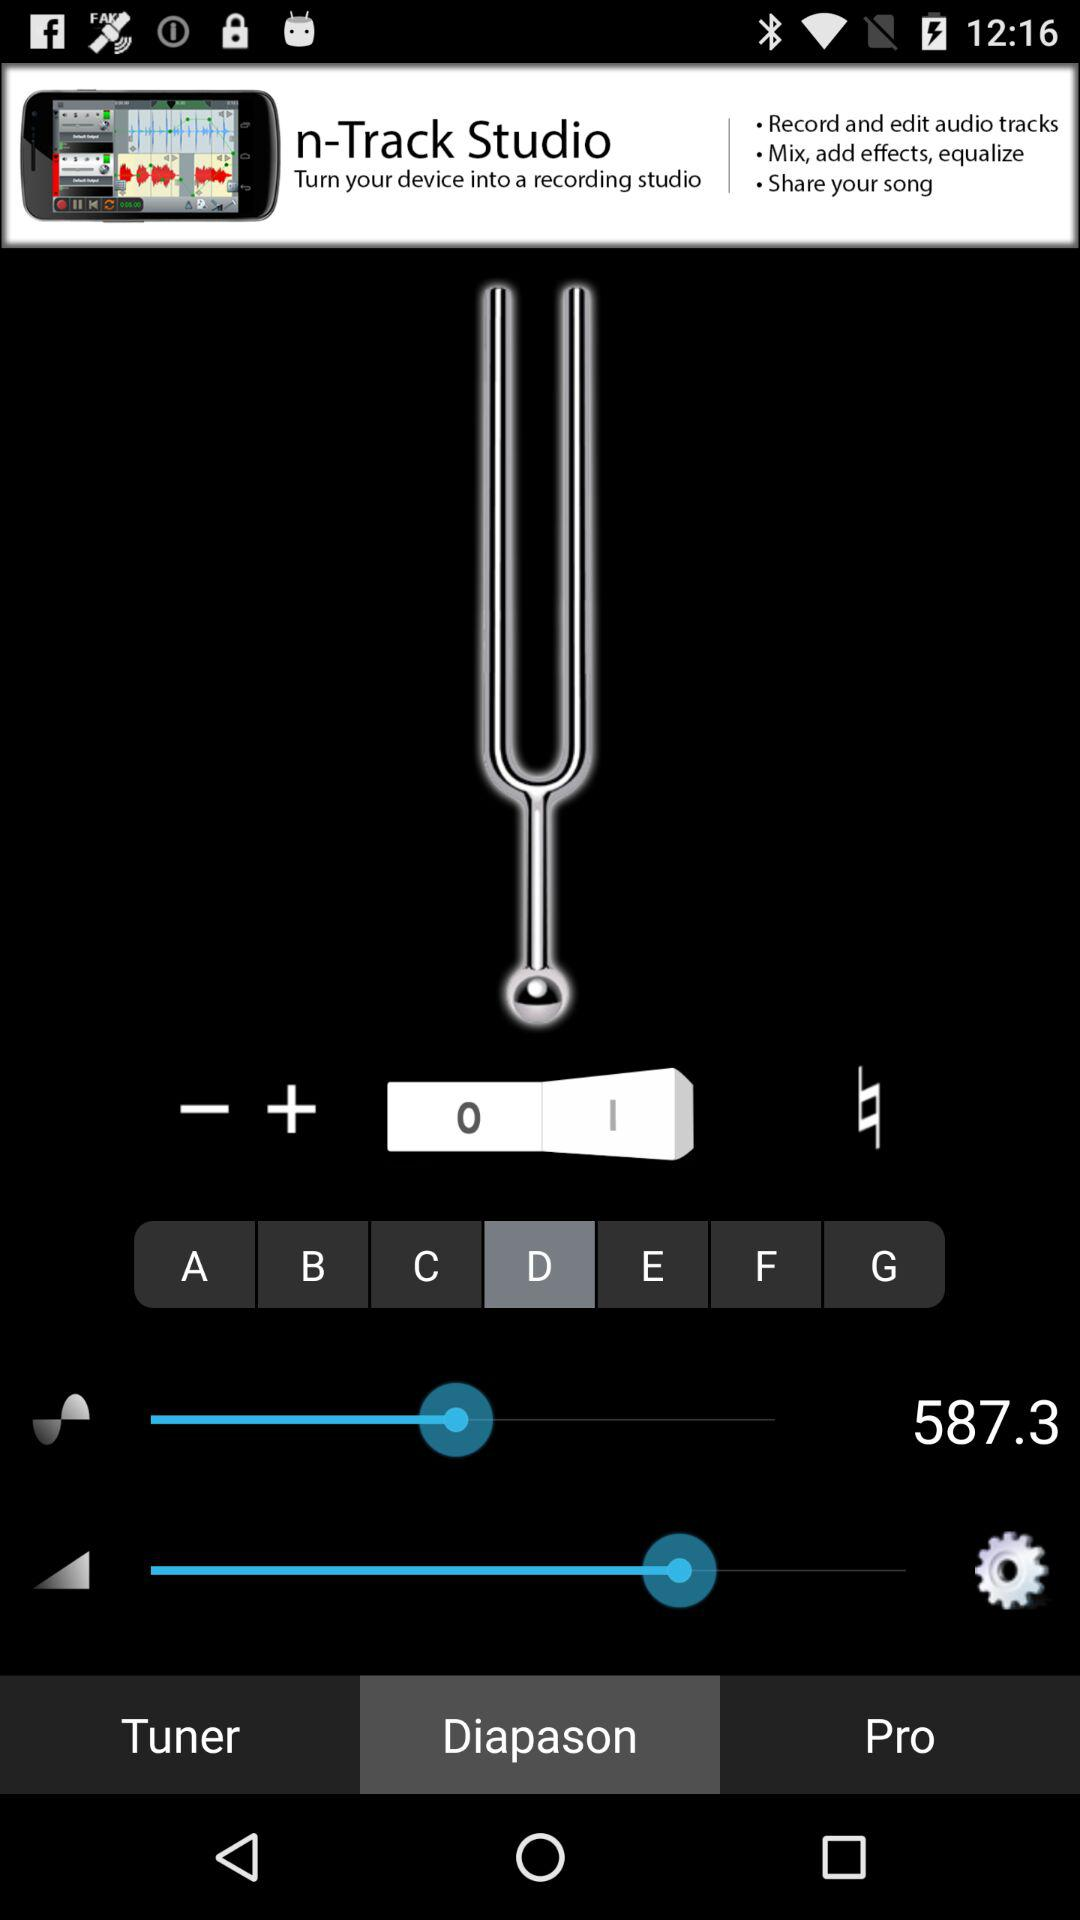Which tab is selected? The selected tab is "Diapason". 